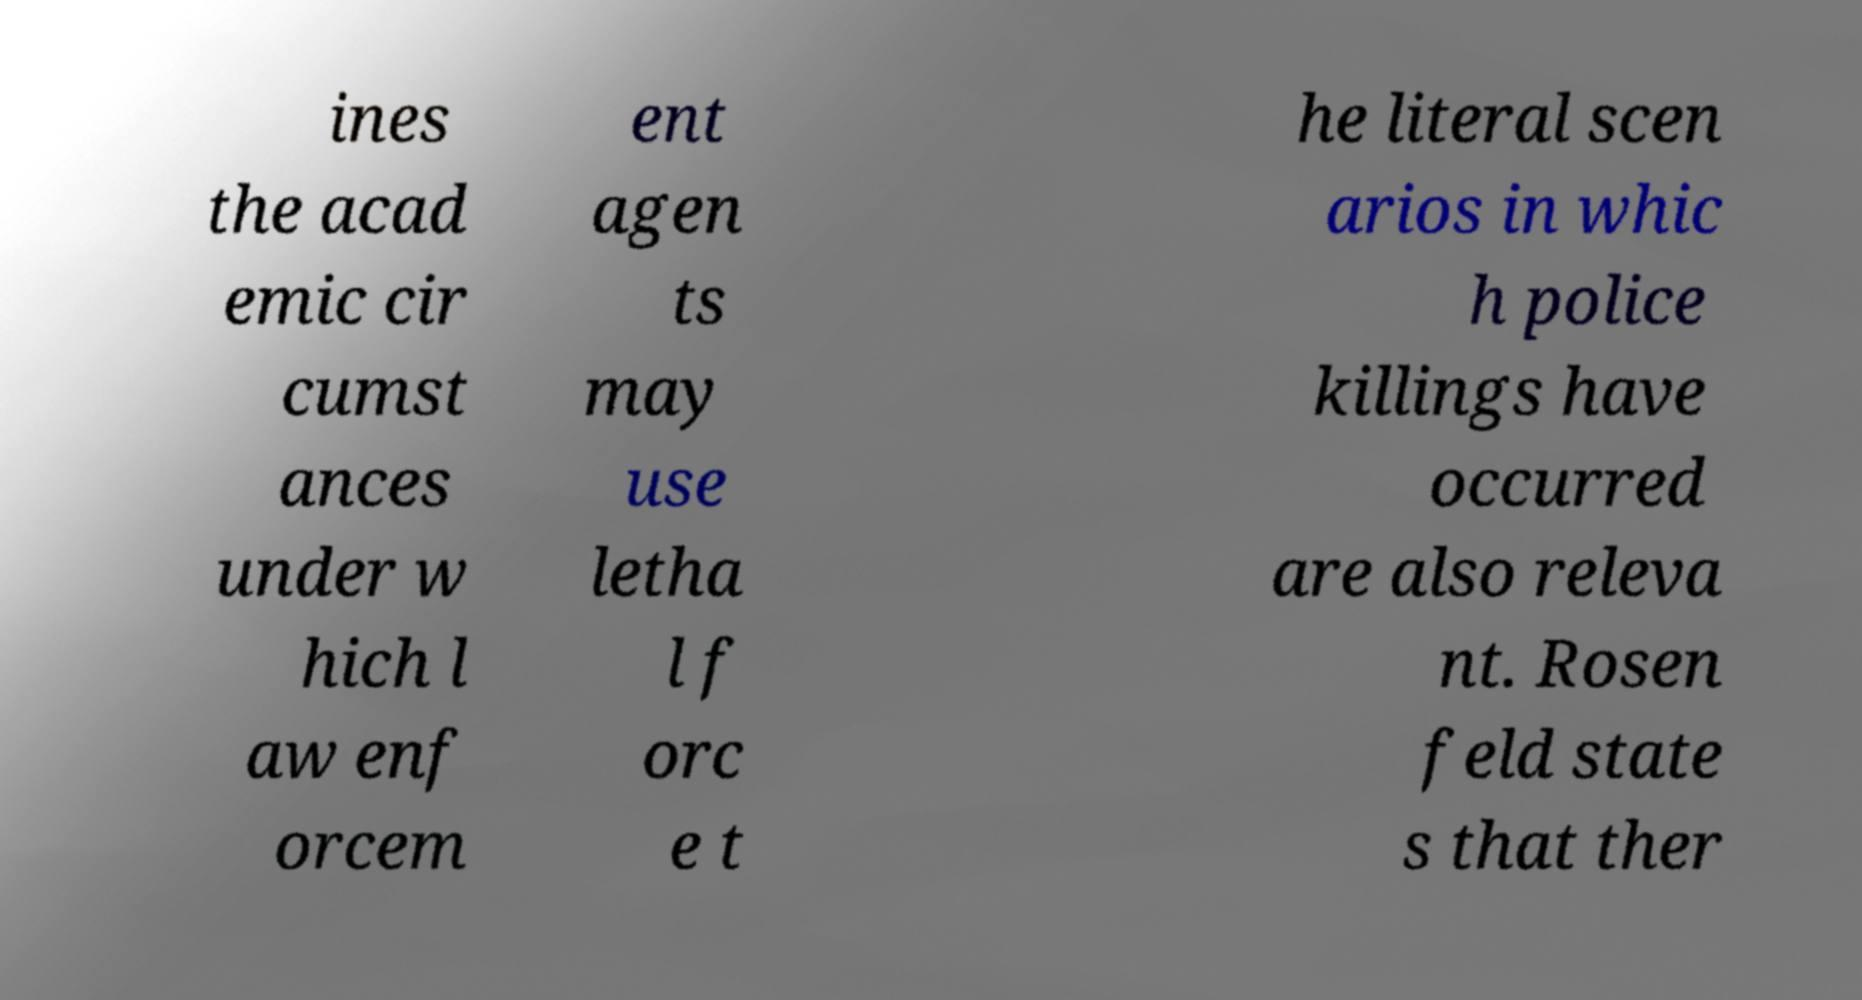Please identify and transcribe the text found in this image. ines the acad emic cir cumst ances under w hich l aw enf orcem ent agen ts may use letha l f orc e t he literal scen arios in whic h police killings have occurred are also releva nt. Rosen feld state s that ther 